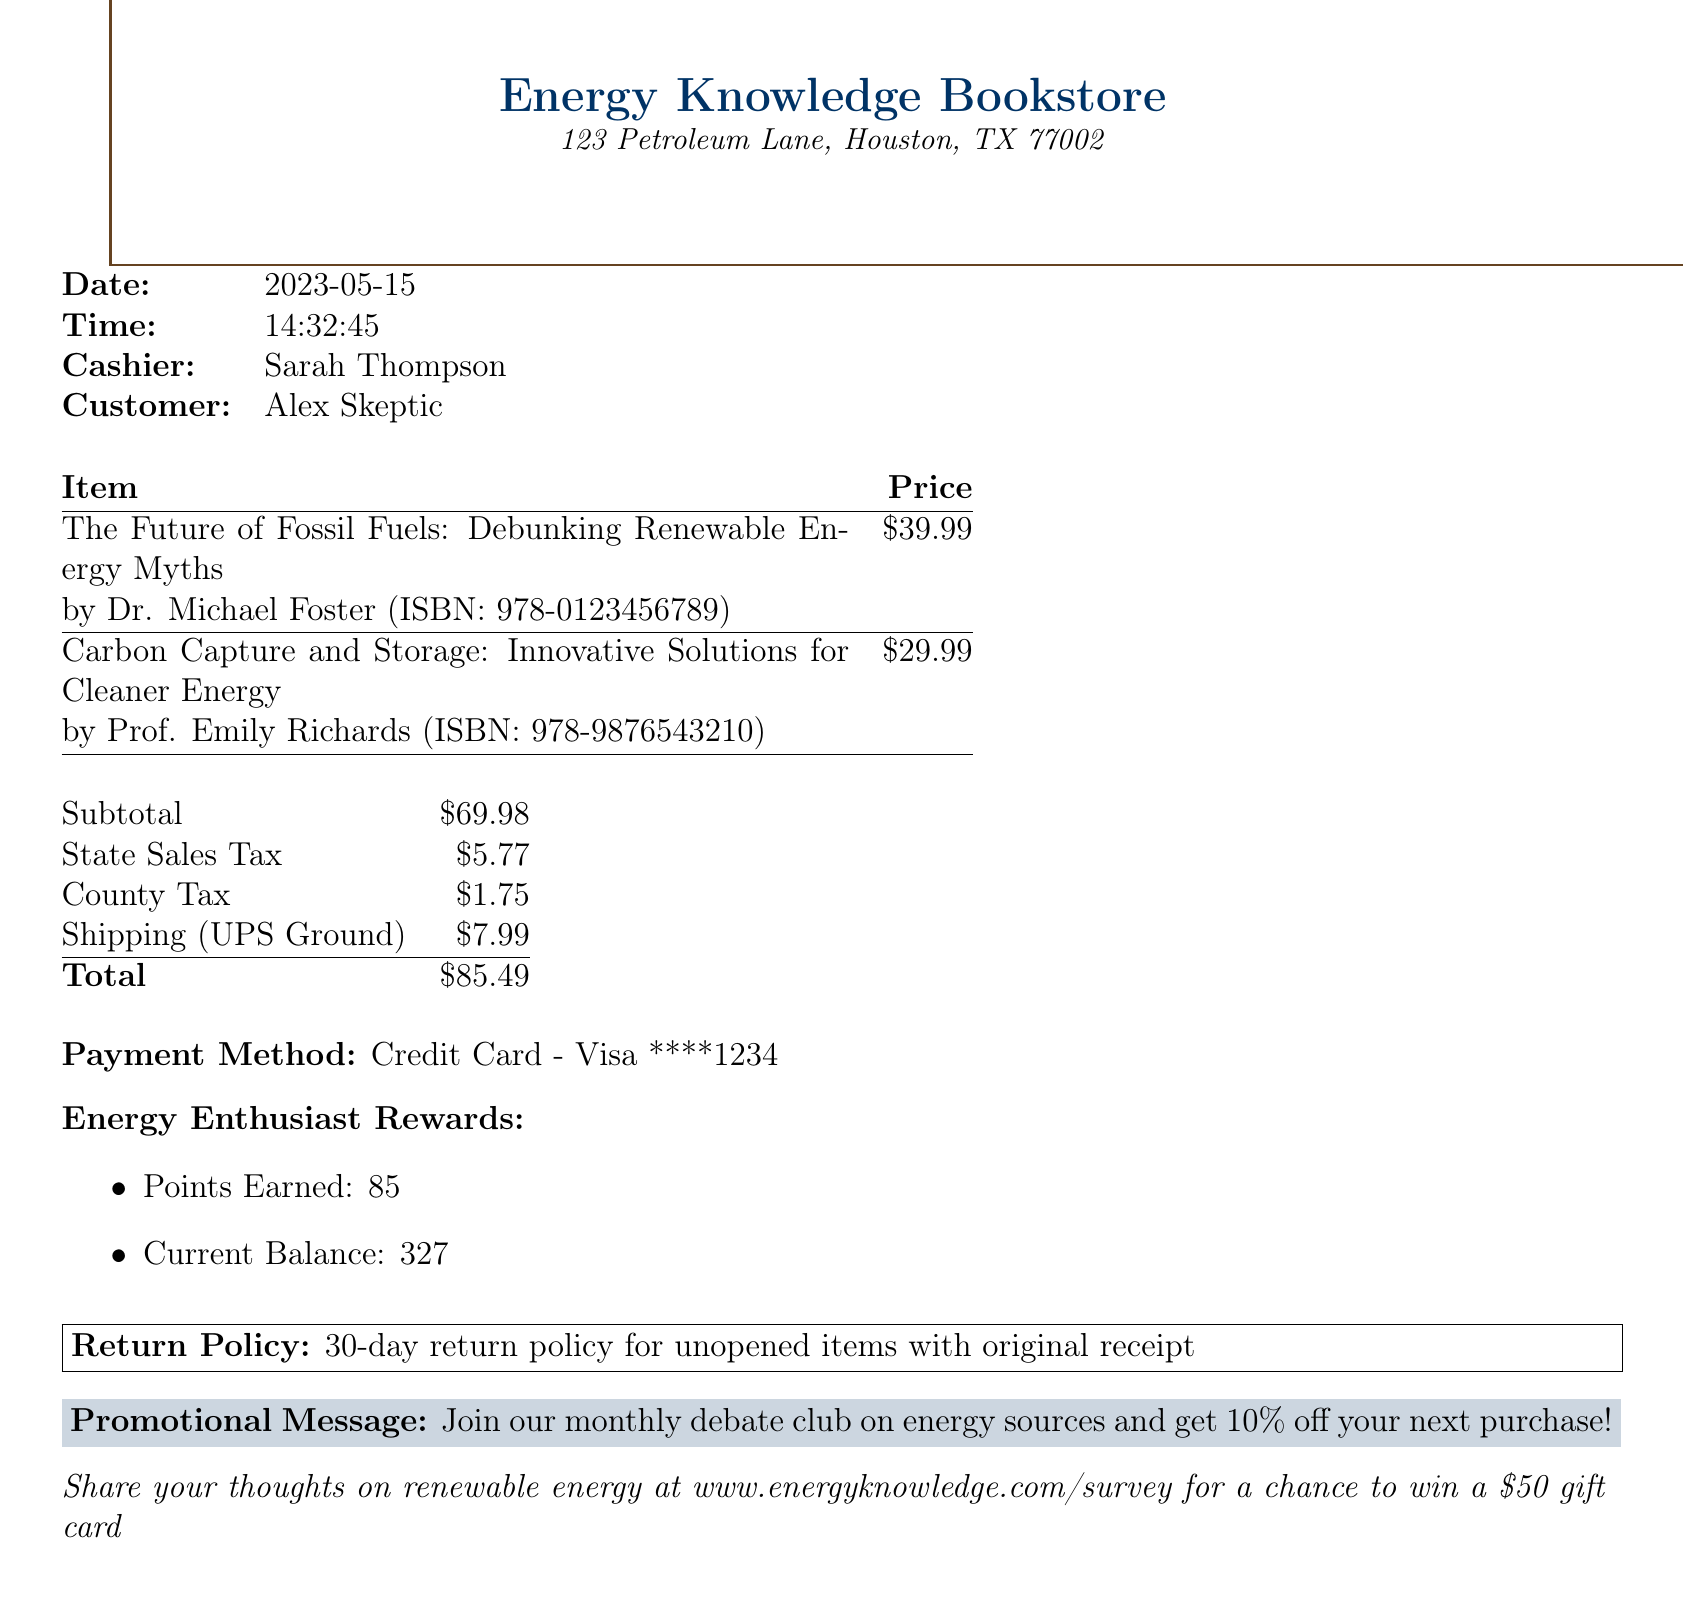What is the name of the first book purchased? The name of the first book is listed in the items section as "The Future of Fossil Fuels: Debunking Renewable Energy Myths."
Answer: The Future of Fossil Fuels: Debunking Renewable Energy Myths What was the total cost of the purchase? The total cost is found at the bottom of the receipt, which adds up the subtotal, taxes, and shipping cost.
Answer: 85.49 Who is the author of the second book? The second book's author is included in the item details as Prof. Emily Richards.
Answer: Prof. Emily Richards What was the shipping method used? The shipping method is specified in the shipping section of the document as "UPS Ground."
Answer: UPS Ground How much was earned in loyalty points? The points earned from the purchase are listed in the loyalty program section as 85.
Answer: 85 What is the return policy duration? The return policy duration is stated in the return policy section of the receipt as "30-day return policy."
Answer: 30-day return policy What sales tax was charged? The state sales tax is provided in the taxes section of the receipt and is listed as 5.77.
Answer: 5.77 What is the name of the store? The name of the store is indicated at the top of the receipt, which is "Energy Knowledge Bookstore."
Answer: Energy Knowledge Bookstore What type of payment was used? The payment method is mentioned in the document as "Credit Card - Visa ****1234."
Answer: Credit Card - Visa ****1234 